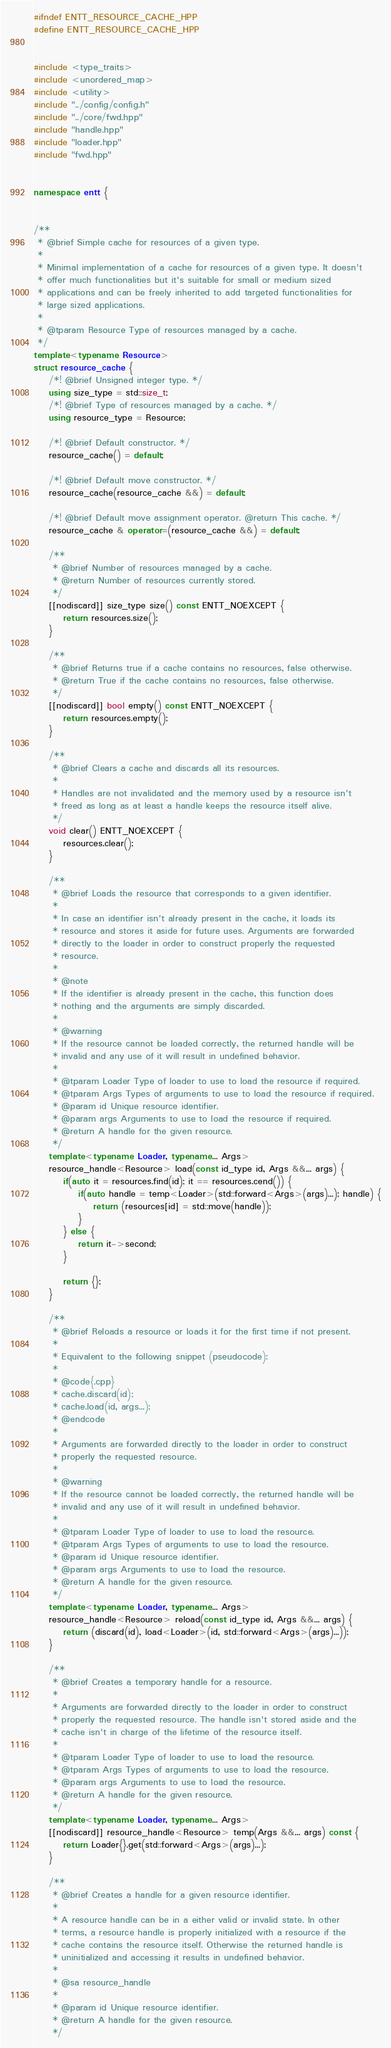<code> <loc_0><loc_0><loc_500><loc_500><_C++_>#ifndef ENTT_RESOURCE_CACHE_HPP
#define ENTT_RESOURCE_CACHE_HPP


#include <type_traits>
#include <unordered_map>
#include <utility>
#include "../config/config.h"
#include "../core/fwd.hpp"
#include "handle.hpp"
#include "loader.hpp"
#include "fwd.hpp"


namespace entt {


/**
 * @brief Simple cache for resources of a given type.
 *
 * Minimal implementation of a cache for resources of a given type. It doesn't
 * offer much functionalities but it's suitable for small or medium sized
 * applications and can be freely inherited to add targeted functionalities for
 * large sized applications.
 *
 * @tparam Resource Type of resources managed by a cache.
 */
template<typename Resource>
struct resource_cache {
    /*! @brief Unsigned integer type. */
    using size_type = std::size_t;
    /*! @brief Type of resources managed by a cache. */
    using resource_type = Resource;

    /*! @brief Default constructor. */
    resource_cache() = default;

    /*! @brief Default move constructor. */
    resource_cache(resource_cache &&) = default;

    /*! @brief Default move assignment operator. @return This cache. */
    resource_cache & operator=(resource_cache &&) = default;

    /**
     * @brief Number of resources managed by a cache.
     * @return Number of resources currently stored.
     */
    [[nodiscard]] size_type size() const ENTT_NOEXCEPT {
        return resources.size();
    }

    /**
     * @brief Returns true if a cache contains no resources, false otherwise.
     * @return True if the cache contains no resources, false otherwise.
     */
    [[nodiscard]] bool empty() const ENTT_NOEXCEPT {
        return resources.empty();
    }

    /**
     * @brief Clears a cache and discards all its resources.
     *
     * Handles are not invalidated and the memory used by a resource isn't
     * freed as long as at least a handle keeps the resource itself alive.
     */
    void clear() ENTT_NOEXCEPT {
        resources.clear();
    }

    /**
     * @brief Loads the resource that corresponds to a given identifier.
     *
     * In case an identifier isn't already present in the cache, it loads its
     * resource and stores it aside for future uses. Arguments are forwarded
     * directly to the loader in order to construct properly the requested
     * resource.
     *
     * @note
     * If the identifier is already present in the cache, this function does
     * nothing and the arguments are simply discarded.
     *
     * @warning
     * If the resource cannot be loaded correctly, the returned handle will be
     * invalid and any use of it will result in undefined behavior.
     *
     * @tparam Loader Type of loader to use to load the resource if required.
     * @tparam Args Types of arguments to use to load the resource if required.
     * @param id Unique resource identifier.
     * @param args Arguments to use to load the resource if required.
     * @return A handle for the given resource.
     */
    template<typename Loader, typename... Args>
    resource_handle<Resource> load(const id_type id, Args &&... args) {
        if(auto it = resources.find(id); it == resources.cend()) {
            if(auto handle = temp<Loader>(std::forward<Args>(args)...); handle) {
                return (resources[id] = std::move(handle));
            }
        } else {
            return it->second;
        }

        return {};
    }

    /**
     * @brief Reloads a resource or loads it for the first time if not present.
     *
     * Equivalent to the following snippet (pseudocode):
     *
     * @code{.cpp}
     * cache.discard(id);
     * cache.load(id, args...);
     * @endcode
     *
     * Arguments are forwarded directly to the loader in order to construct
     * properly the requested resource.
     *
     * @warning
     * If the resource cannot be loaded correctly, the returned handle will be
     * invalid and any use of it will result in undefined behavior.
     *
     * @tparam Loader Type of loader to use to load the resource.
     * @tparam Args Types of arguments to use to load the resource.
     * @param id Unique resource identifier.
     * @param args Arguments to use to load the resource.
     * @return A handle for the given resource.
     */
    template<typename Loader, typename... Args>
    resource_handle<Resource> reload(const id_type id, Args &&... args) {
        return (discard(id), load<Loader>(id, std::forward<Args>(args)...));
    }

    /**
     * @brief Creates a temporary handle for a resource.
     *
     * Arguments are forwarded directly to the loader in order to construct
     * properly the requested resource. The handle isn't stored aside and the
     * cache isn't in charge of the lifetime of the resource itself.
     *
     * @tparam Loader Type of loader to use to load the resource.
     * @tparam Args Types of arguments to use to load the resource.
     * @param args Arguments to use to load the resource.
     * @return A handle for the given resource.
     */
    template<typename Loader, typename... Args>
    [[nodiscard]] resource_handle<Resource> temp(Args &&... args) const {
        return Loader{}.get(std::forward<Args>(args)...);
    }

    /**
     * @brief Creates a handle for a given resource identifier.
     *
     * A resource handle can be in a either valid or invalid state. In other
     * terms, a resource handle is properly initialized with a resource if the
     * cache contains the resource itself. Otherwise the returned handle is
     * uninitialized and accessing it results in undefined behavior.
     *
     * @sa resource_handle
     *
     * @param id Unique resource identifier.
     * @return A handle for the given resource.
     */</code> 